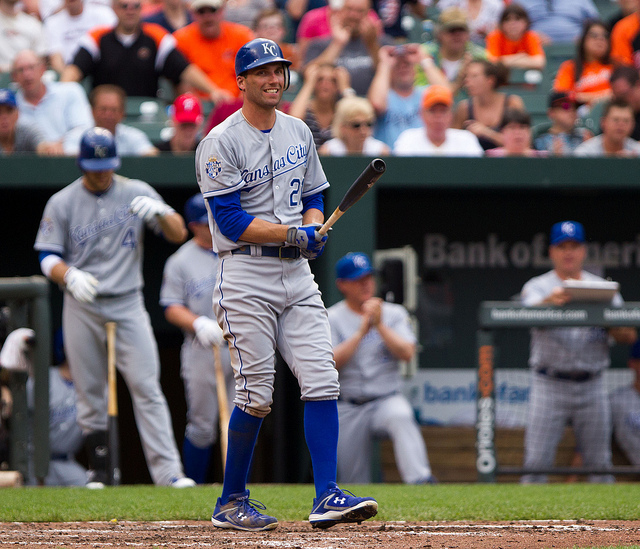Please identify all text content in this image. ansas City 2 Bank 4 KC H 